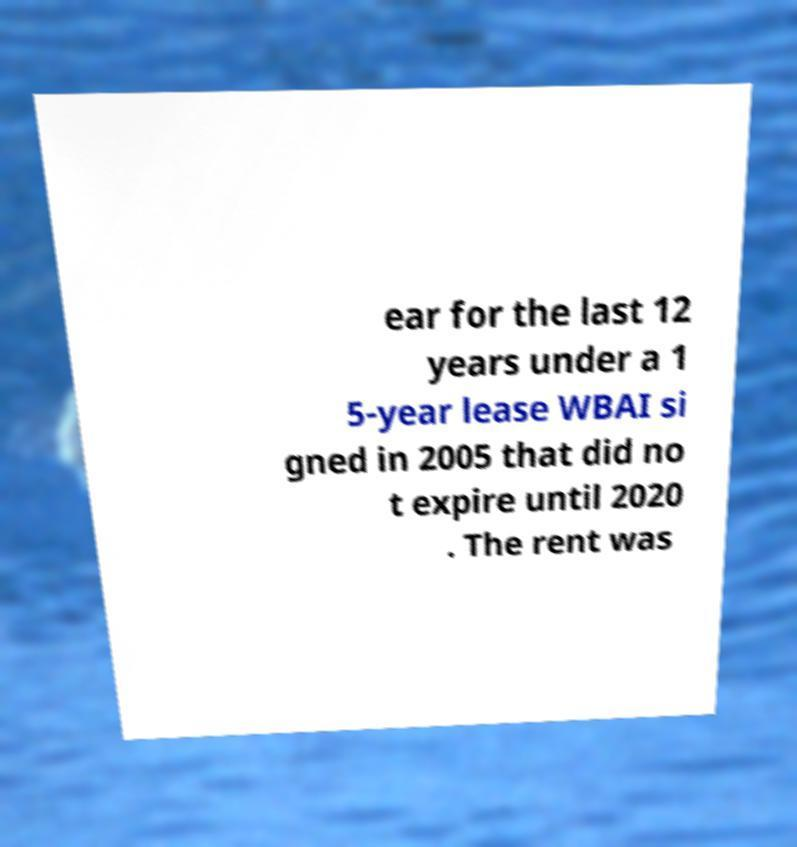Please identify and transcribe the text found in this image. ear for the last 12 years under a 1 5-year lease WBAI si gned in 2005 that did no t expire until 2020 . The rent was 